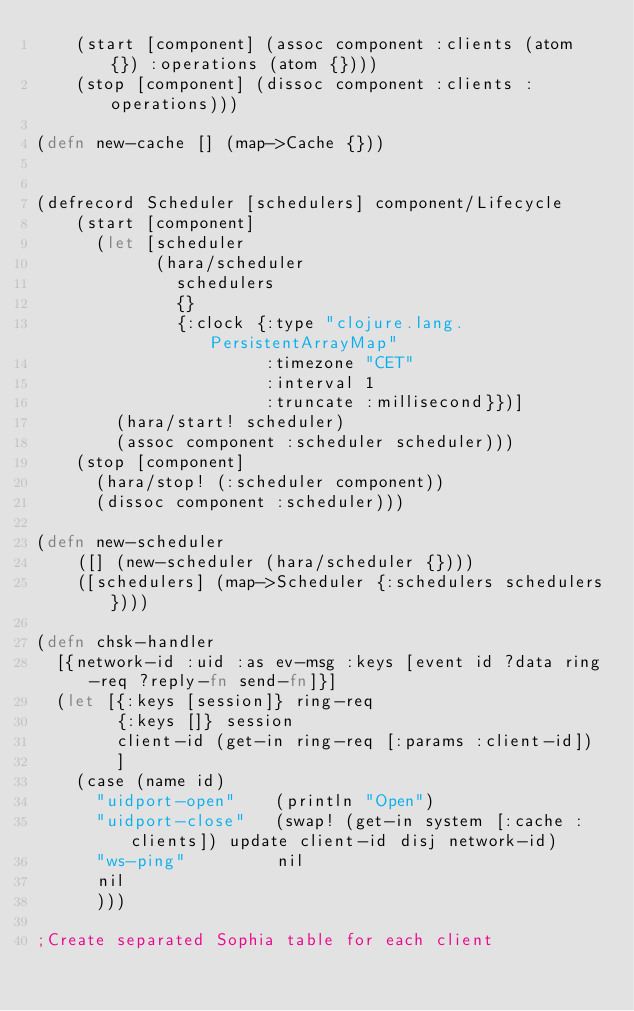<code> <loc_0><loc_0><loc_500><loc_500><_Clojure_>    (start [component] (assoc component :clients (atom {}) :operations (atom {})))
    (stop [component] (dissoc component :clients :operations)))

(defn new-cache [] (map->Cache {}))


(defrecord Scheduler [schedulers] component/Lifecycle
    (start [component] 
      (let [scheduler 
            (hara/scheduler
              schedulers
              {}
              {:clock {:type "clojure.lang.PersistentArrayMap"
                       :timezone "CET"
                       :interval 1
                       :truncate :millisecond}})]
        (hara/start! scheduler) 
        (assoc component :scheduler scheduler)))
    (stop [component] 
      (hara/stop! (:scheduler component)) 
      (dissoc component :scheduler)))

(defn new-scheduler
    ([] (new-scheduler (hara/scheduler {})))
    ([schedulers] (map->Scheduler {:schedulers schedulers})))

(defn chsk-handler
  [{network-id :uid :as ev-msg :keys [event id ?data ring-req ?reply-fn send-fn]}]
  (let [{:keys [session]} ring-req
        {:keys []} session
        client-id (get-in ring-req [:params :client-id])
        ]
    (case (name id)
      "uidport-open"    (println "Open")
      "uidport-close"   (swap! (get-in system [:cache :clients]) update client-id disj network-id) 
      "ws-ping"         nil
      nil
      )))

;Create separated Sophia table for each client</code> 